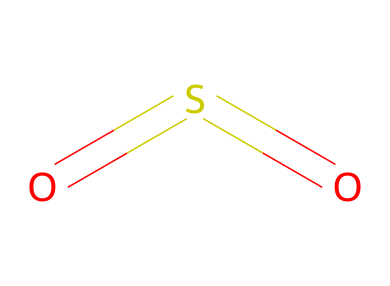What is the molecular formula of this compound? The SMILES representation shows one sulfur (S) atom and two oxygen (O) atoms, which gives the molecular formula as SO2.
Answer: SO2 How many double bonds are present in sulfur dioxide? The structure O=S=O indicates that there are two double bonds, one between sulfur and each oxygen atom.
Answer: 2 What type of intermolecular forces are present in sulfur dioxide? Due to its polar nature, sulfur dioxide primarily exhibits dipole-dipole interactions among its molecules.
Answer: dipole-dipole What is the oxidation state of sulfur in this compound? Sulfur in SO2 is in the +4 oxidation state, calculated based on the overall charge of the molecule and the known charges of oxygen.
Answer: +4 Is sulfur dioxide a nonpolar or polar molecule? The bent shape of the molecule due to the lone pairs of electrons on sulfur causes an asymmetrical distribution of charge, making it polar.
Answer: polar What physical state is sulfur dioxide at room temperature? Sulfur dioxide is a gas at room temperature under standard atmospheric conditions.
Answer: gas What is the common use of sulfur dioxide beyond being an air pollutant? Sulfur dioxide is commonly used as a preservative and antioxidant in food and beverages, particularly dried fruits and wines.
Answer: preservative 